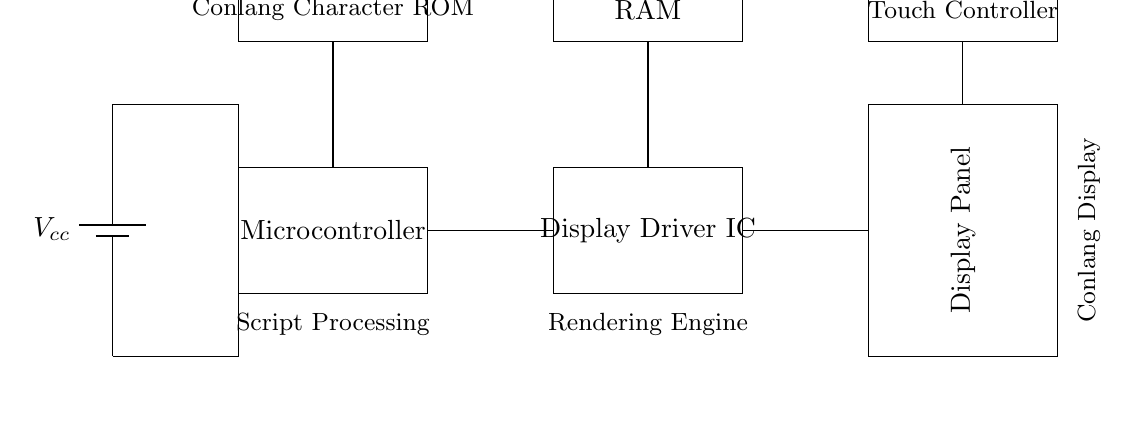What is the main power supply voltage in this circuit? The main power supply voltage is indicated by the battery symbol labeled Vcc. It generally supplies the circuit components with the necessary voltage for operation, commonly being a positive voltage value.
Answer: Vcc How many primary components are in the circuit? By counting the distinct rectangular blocks that represent the components in the diagram, we can identify the microcontroller, display driver IC, display panel, conlang character ROM, RAM, and touch controller. Adding these gives a total of six primary components.
Answer: Six Which component is responsible for processing conlang scripts? The conlang character ROM specifically holds the data or codes for the conlang scripts, making it the component responsible for processing these scripts into a format suitable for display.
Answer: Conlang Character ROM What is the function of the RAM in this circuit? The RAM serves as temporary storage for data that the display driver or microcontroller will use during operation. It allows for quick access to data that needs to be processed or rendered on the display.
Answer: Temporary storage Which component interfaces with the user’s touch input? The touch controller is the component that allows for user interaction via touch input, processing the signals from the touch screen and sending them to the relevant part of the system.
Answer: Touch Controller How does the display panel connect to the display driver IC? The display panel connects directly to the display driver IC through a line that runs from the output side of the driver IC to the input side of the display panel, allowing for the driving signals necessary for display rendering.
Answer: Direct connection 